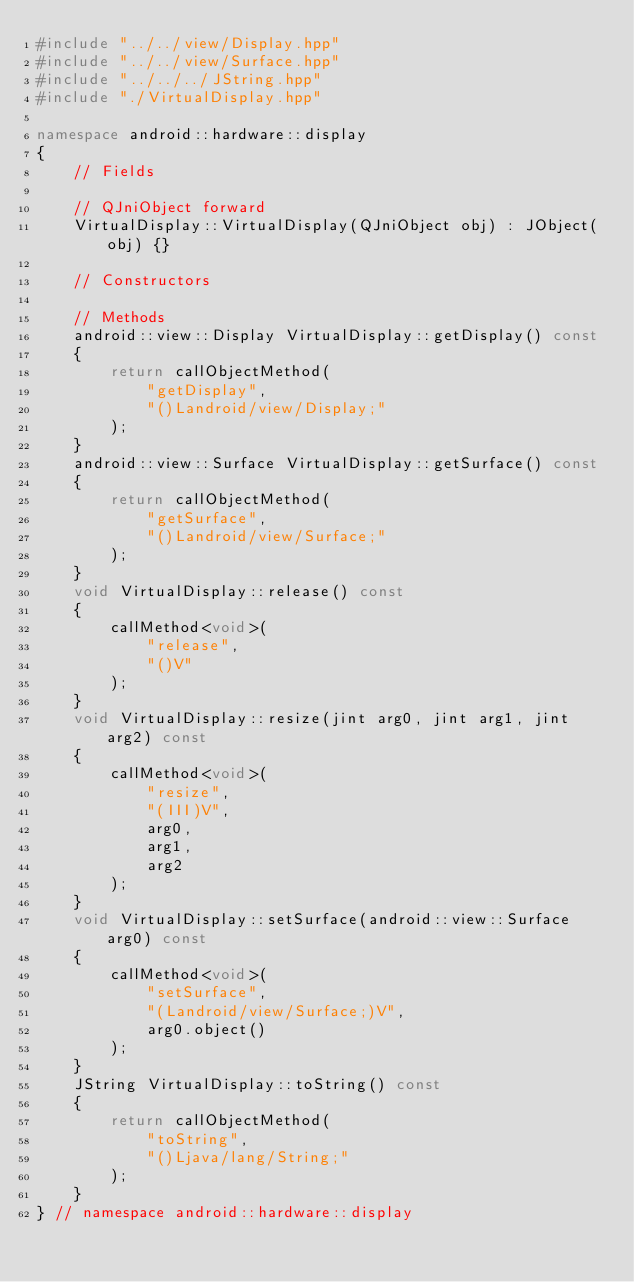Convert code to text. <code><loc_0><loc_0><loc_500><loc_500><_C++_>#include "../../view/Display.hpp"
#include "../../view/Surface.hpp"
#include "../../../JString.hpp"
#include "./VirtualDisplay.hpp"

namespace android::hardware::display
{
	// Fields
	
	// QJniObject forward
	VirtualDisplay::VirtualDisplay(QJniObject obj) : JObject(obj) {}
	
	// Constructors
	
	// Methods
	android::view::Display VirtualDisplay::getDisplay() const
	{
		return callObjectMethod(
			"getDisplay",
			"()Landroid/view/Display;"
		);
	}
	android::view::Surface VirtualDisplay::getSurface() const
	{
		return callObjectMethod(
			"getSurface",
			"()Landroid/view/Surface;"
		);
	}
	void VirtualDisplay::release() const
	{
		callMethod<void>(
			"release",
			"()V"
		);
	}
	void VirtualDisplay::resize(jint arg0, jint arg1, jint arg2) const
	{
		callMethod<void>(
			"resize",
			"(III)V",
			arg0,
			arg1,
			arg2
		);
	}
	void VirtualDisplay::setSurface(android::view::Surface arg0) const
	{
		callMethod<void>(
			"setSurface",
			"(Landroid/view/Surface;)V",
			arg0.object()
		);
	}
	JString VirtualDisplay::toString() const
	{
		return callObjectMethod(
			"toString",
			"()Ljava/lang/String;"
		);
	}
} // namespace android::hardware::display

</code> 